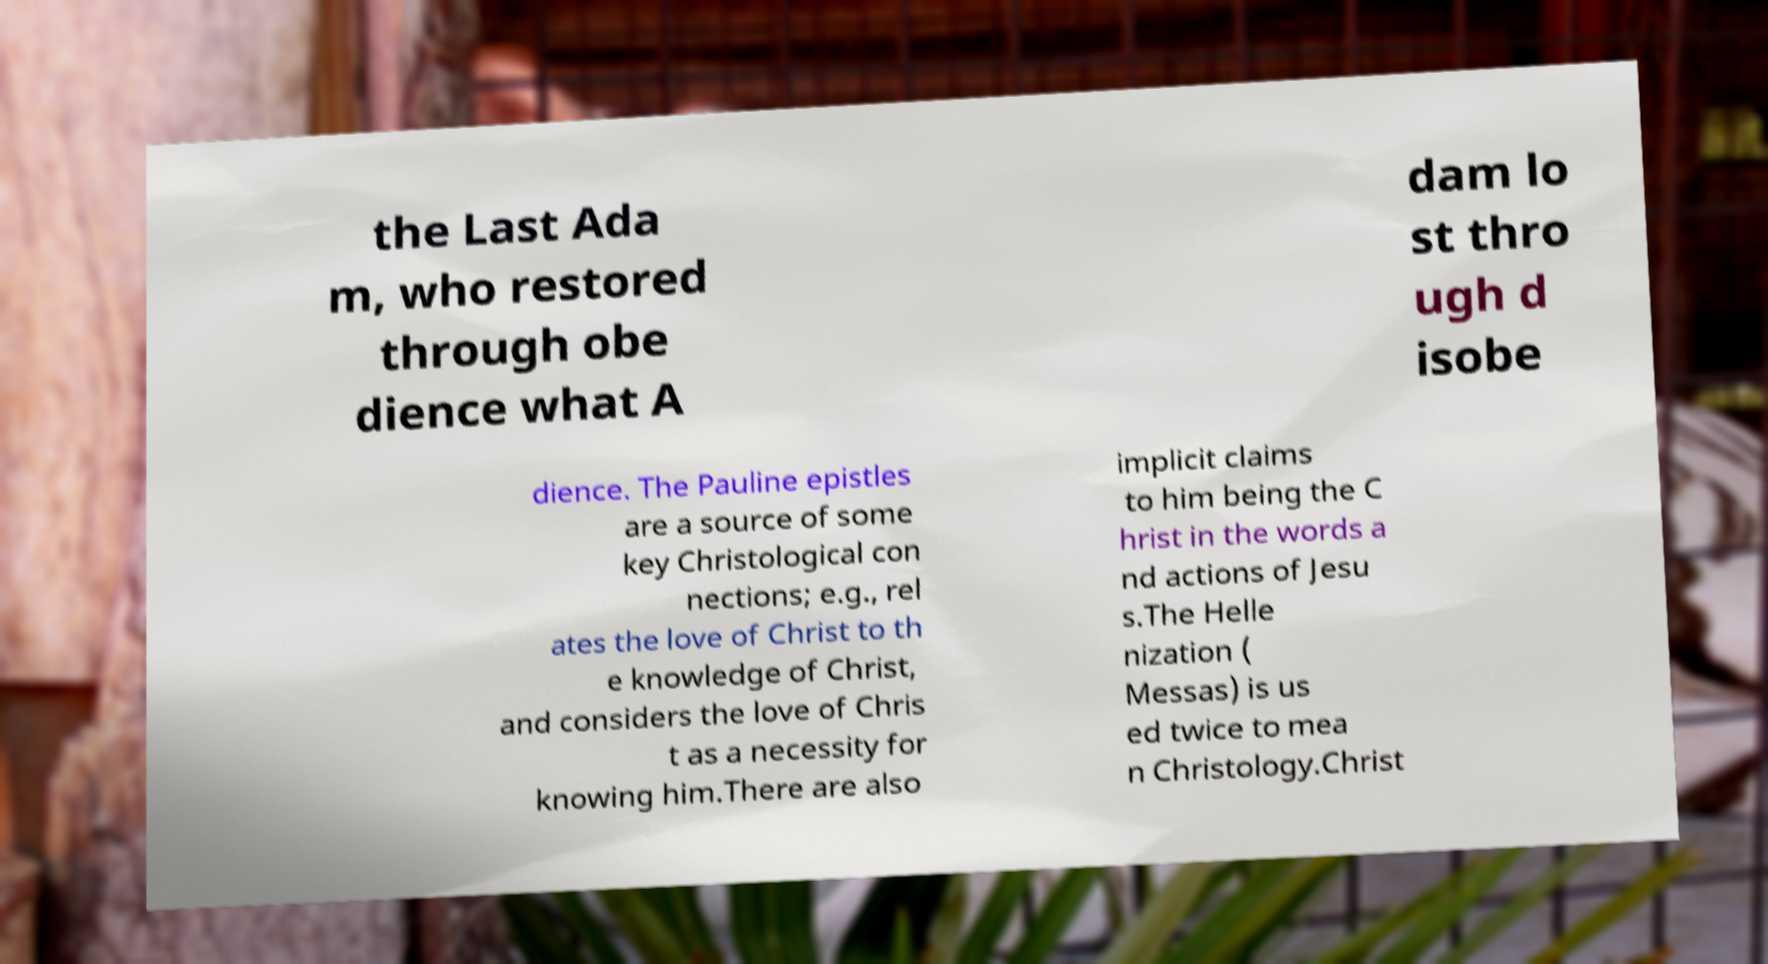What messages or text are displayed in this image? I need them in a readable, typed format. the Last Ada m, who restored through obe dience what A dam lo st thro ugh d isobe dience. The Pauline epistles are a source of some key Christological con nections; e.g., rel ates the love of Christ to th e knowledge of Christ, and considers the love of Chris t as a necessity for knowing him.There are also implicit claims to him being the C hrist in the words a nd actions of Jesu s.The Helle nization ( Messas) is us ed twice to mea n Christology.Christ 